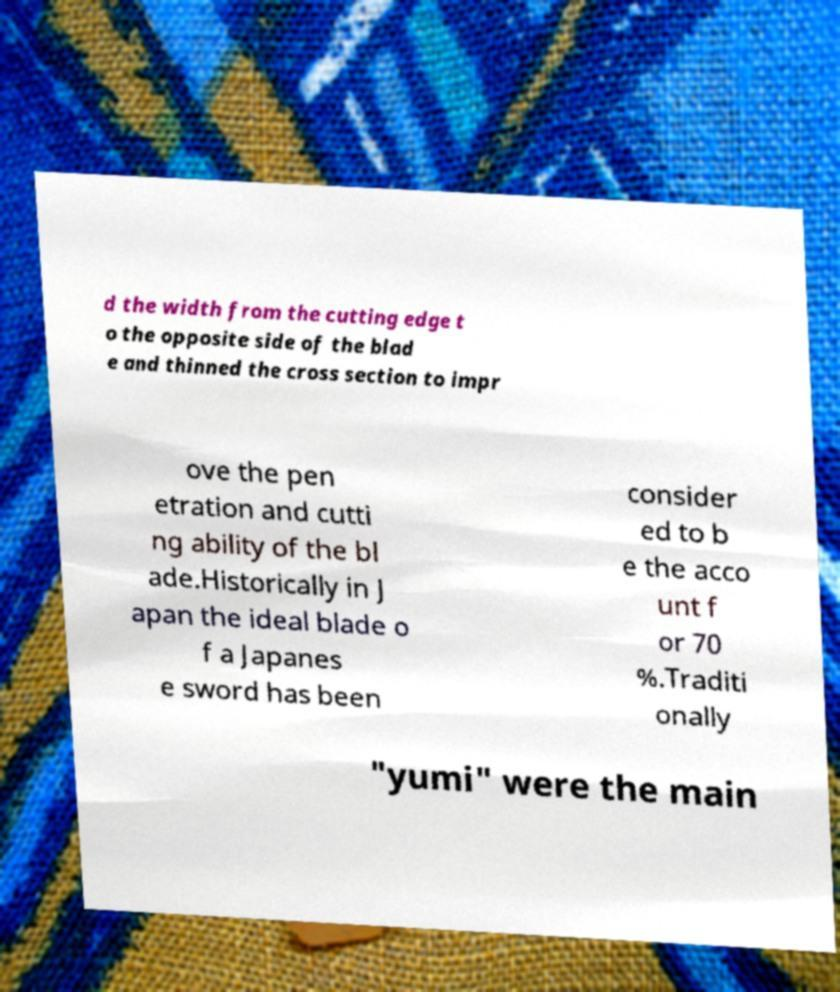Could you assist in decoding the text presented in this image and type it out clearly? d the width from the cutting edge t o the opposite side of the blad e and thinned the cross section to impr ove the pen etration and cutti ng ability of the bl ade.Historically in J apan the ideal blade o f a Japanes e sword has been consider ed to b e the acco unt f or 70 %.Traditi onally "yumi" were the main 